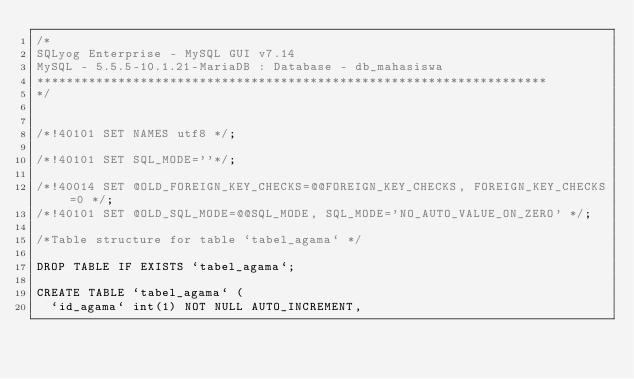<code> <loc_0><loc_0><loc_500><loc_500><_SQL_>/*
SQLyog Enterprise - MySQL GUI v7.14 
MySQL - 5.5.5-10.1.21-MariaDB : Database - db_mahasiswa
*********************************************************************
*/

/*!40101 SET NAMES utf8 */;

/*!40101 SET SQL_MODE=''*/;

/*!40014 SET @OLD_FOREIGN_KEY_CHECKS=@@FOREIGN_KEY_CHECKS, FOREIGN_KEY_CHECKS=0 */;
/*!40101 SET @OLD_SQL_MODE=@@SQL_MODE, SQL_MODE='NO_AUTO_VALUE_ON_ZERO' */;

/*Table structure for table `tabel_agama` */

DROP TABLE IF EXISTS `tabel_agama`;

CREATE TABLE `tabel_agama` (
  `id_agama` int(1) NOT NULL AUTO_INCREMENT,</code> 